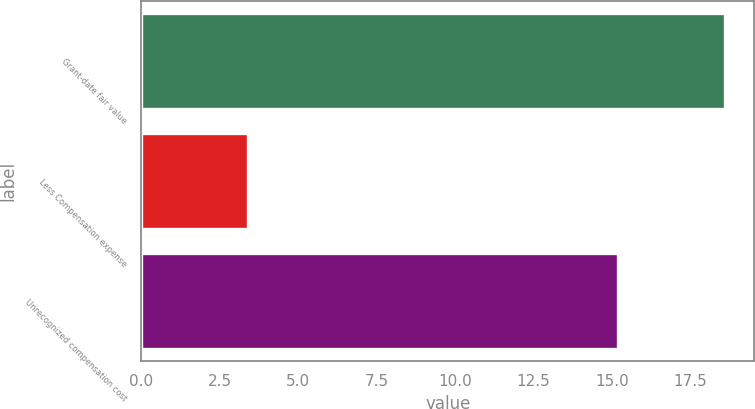Convert chart to OTSL. <chart><loc_0><loc_0><loc_500><loc_500><bar_chart><fcel>Grant-date fair value<fcel>Less Compensation expense<fcel>Unrecognized compensation cost<nl><fcel>18.6<fcel>3.4<fcel>15.2<nl></chart> 